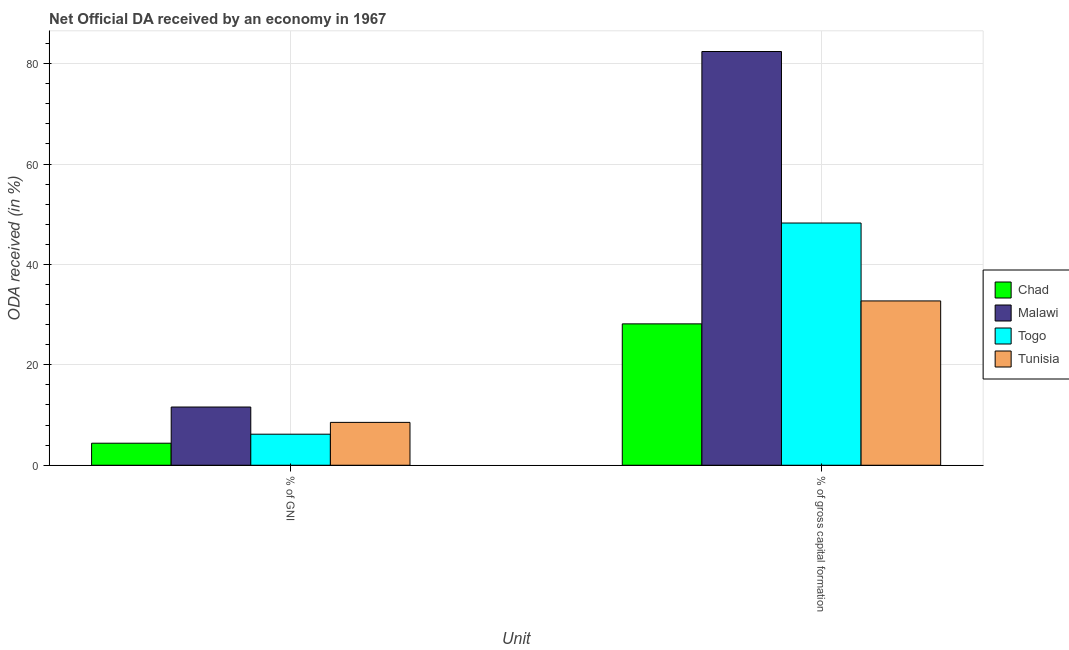How many different coloured bars are there?
Your answer should be compact. 4. How many groups of bars are there?
Keep it short and to the point. 2. What is the label of the 2nd group of bars from the left?
Keep it short and to the point. % of gross capital formation. What is the oda received as percentage of gni in Malawi?
Offer a terse response. 11.6. Across all countries, what is the maximum oda received as percentage of gni?
Your answer should be compact. 11.6. Across all countries, what is the minimum oda received as percentage of gross capital formation?
Offer a very short reply. 28.16. In which country was the oda received as percentage of gross capital formation maximum?
Provide a short and direct response. Malawi. In which country was the oda received as percentage of gni minimum?
Your answer should be compact. Chad. What is the total oda received as percentage of gross capital formation in the graph?
Give a very brief answer. 191.54. What is the difference between the oda received as percentage of gross capital formation in Tunisia and that in Chad?
Your response must be concise. 4.57. What is the difference between the oda received as percentage of gni in Tunisia and the oda received as percentage of gross capital formation in Chad?
Your response must be concise. -19.62. What is the average oda received as percentage of gni per country?
Give a very brief answer. 7.68. What is the difference between the oda received as percentage of gni and oda received as percentage of gross capital formation in Chad?
Offer a terse response. -23.77. In how many countries, is the oda received as percentage of gross capital formation greater than 72 %?
Keep it short and to the point. 1. What is the ratio of the oda received as percentage of gni in Chad to that in Togo?
Offer a very short reply. 0.71. In how many countries, is the oda received as percentage of gross capital formation greater than the average oda received as percentage of gross capital formation taken over all countries?
Your response must be concise. 2. What does the 3rd bar from the left in % of gross capital formation represents?
Give a very brief answer. Togo. What does the 2nd bar from the right in % of GNI represents?
Your answer should be compact. Togo. How many bars are there?
Provide a succinct answer. 8. Are all the bars in the graph horizontal?
Keep it short and to the point. No. How many countries are there in the graph?
Offer a terse response. 4. Does the graph contain any zero values?
Your response must be concise. No. How many legend labels are there?
Offer a terse response. 4. How are the legend labels stacked?
Your answer should be compact. Vertical. What is the title of the graph?
Give a very brief answer. Net Official DA received by an economy in 1967. What is the label or title of the X-axis?
Your response must be concise. Unit. What is the label or title of the Y-axis?
Make the answer very short. ODA received (in %). What is the ODA received (in %) in Chad in % of GNI?
Offer a terse response. 4.39. What is the ODA received (in %) of Malawi in % of GNI?
Give a very brief answer. 11.6. What is the ODA received (in %) of Togo in % of GNI?
Provide a succinct answer. 6.18. What is the ODA received (in %) in Tunisia in % of GNI?
Offer a terse response. 8.54. What is the ODA received (in %) in Chad in % of gross capital formation?
Provide a short and direct response. 28.16. What is the ODA received (in %) in Malawi in % of gross capital formation?
Keep it short and to the point. 82.41. What is the ODA received (in %) of Togo in % of gross capital formation?
Give a very brief answer. 48.24. What is the ODA received (in %) in Tunisia in % of gross capital formation?
Your answer should be compact. 32.73. Across all Unit, what is the maximum ODA received (in %) of Chad?
Give a very brief answer. 28.16. Across all Unit, what is the maximum ODA received (in %) in Malawi?
Keep it short and to the point. 82.41. Across all Unit, what is the maximum ODA received (in %) in Togo?
Your answer should be very brief. 48.24. Across all Unit, what is the maximum ODA received (in %) of Tunisia?
Provide a succinct answer. 32.73. Across all Unit, what is the minimum ODA received (in %) of Chad?
Give a very brief answer. 4.39. Across all Unit, what is the minimum ODA received (in %) of Malawi?
Your answer should be compact. 11.6. Across all Unit, what is the minimum ODA received (in %) in Togo?
Offer a terse response. 6.18. Across all Unit, what is the minimum ODA received (in %) of Tunisia?
Provide a short and direct response. 8.54. What is the total ODA received (in %) of Chad in the graph?
Offer a very short reply. 32.54. What is the total ODA received (in %) in Malawi in the graph?
Provide a succinct answer. 94. What is the total ODA received (in %) of Togo in the graph?
Make the answer very short. 54.43. What is the total ODA received (in %) of Tunisia in the graph?
Provide a succinct answer. 41.26. What is the difference between the ODA received (in %) of Chad in % of GNI and that in % of gross capital formation?
Make the answer very short. -23.77. What is the difference between the ODA received (in %) in Malawi in % of GNI and that in % of gross capital formation?
Make the answer very short. -70.81. What is the difference between the ODA received (in %) of Togo in % of GNI and that in % of gross capital formation?
Your answer should be compact. -42.06. What is the difference between the ODA received (in %) of Tunisia in % of GNI and that in % of gross capital formation?
Make the answer very short. -24.19. What is the difference between the ODA received (in %) in Chad in % of GNI and the ODA received (in %) in Malawi in % of gross capital formation?
Provide a succinct answer. -78.02. What is the difference between the ODA received (in %) in Chad in % of GNI and the ODA received (in %) in Togo in % of gross capital formation?
Offer a terse response. -43.86. What is the difference between the ODA received (in %) in Chad in % of GNI and the ODA received (in %) in Tunisia in % of gross capital formation?
Ensure brevity in your answer.  -28.34. What is the difference between the ODA received (in %) in Malawi in % of GNI and the ODA received (in %) in Togo in % of gross capital formation?
Your answer should be compact. -36.65. What is the difference between the ODA received (in %) of Malawi in % of GNI and the ODA received (in %) of Tunisia in % of gross capital formation?
Your answer should be very brief. -21.13. What is the difference between the ODA received (in %) in Togo in % of GNI and the ODA received (in %) in Tunisia in % of gross capital formation?
Offer a very short reply. -26.54. What is the average ODA received (in %) in Chad per Unit?
Give a very brief answer. 16.27. What is the average ODA received (in %) of Malawi per Unit?
Your answer should be compact. 47. What is the average ODA received (in %) of Togo per Unit?
Your answer should be compact. 27.21. What is the average ODA received (in %) in Tunisia per Unit?
Provide a succinct answer. 20.63. What is the difference between the ODA received (in %) of Chad and ODA received (in %) of Malawi in % of GNI?
Give a very brief answer. -7.21. What is the difference between the ODA received (in %) of Chad and ODA received (in %) of Togo in % of GNI?
Offer a very short reply. -1.8. What is the difference between the ODA received (in %) in Chad and ODA received (in %) in Tunisia in % of GNI?
Provide a short and direct response. -4.15. What is the difference between the ODA received (in %) of Malawi and ODA received (in %) of Togo in % of GNI?
Ensure brevity in your answer.  5.41. What is the difference between the ODA received (in %) in Malawi and ODA received (in %) in Tunisia in % of GNI?
Provide a short and direct response. 3.06. What is the difference between the ODA received (in %) in Togo and ODA received (in %) in Tunisia in % of GNI?
Keep it short and to the point. -2.35. What is the difference between the ODA received (in %) of Chad and ODA received (in %) of Malawi in % of gross capital formation?
Your response must be concise. -54.25. What is the difference between the ODA received (in %) of Chad and ODA received (in %) of Togo in % of gross capital formation?
Provide a succinct answer. -20.09. What is the difference between the ODA received (in %) of Chad and ODA received (in %) of Tunisia in % of gross capital formation?
Your answer should be compact. -4.57. What is the difference between the ODA received (in %) in Malawi and ODA received (in %) in Togo in % of gross capital formation?
Offer a terse response. 34.16. What is the difference between the ODA received (in %) of Malawi and ODA received (in %) of Tunisia in % of gross capital formation?
Make the answer very short. 49.68. What is the difference between the ODA received (in %) in Togo and ODA received (in %) in Tunisia in % of gross capital formation?
Give a very brief answer. 15.52. What is the ratio of the ODA received (in %) of Chad in % of GNI to that in % of gross capital formation?
Give a very brief answer. 0.16. What is the ratio of the ODA received (in %) of Malawi in % of GNI to that in % of gross capital formation?
Keep it short and to the point. 0.14. What is the ratio of the ODA received (in %) in Togo in % of GNI to that in % of gross capital formation?
Provide a short and direct response. 0.13. What is the ratio of the ODA received (in %) of Tunisia in % of GNI to that in % of gross capital formation?
Your answer should be compact. 0.26. What is the difference between the highest and the second highest ODA received (in %) in Chad?
Your response must be concise. 23.77. What is the difference between the highest and the second highest ODA received (in %) of Malawi?
Your answer should be very brief. 70.81. What is the difference between the highest and the second highest ODA received (in %) in Togo?
Offer a terse response. 42.06. What is the difference between the highest and the second highest ODA received (in %) in Tunisia?
Make the answer very short. 24.19. What is the difference between the highest and the lowest ODA received (in %) in Chad?
Your answer should be very brief. 23.77. What is the difference between the highest and the lowest ODA received (in %) in Malawi?
Offer a very short reply. 70.81. What is the difference between the highest and the lowest ODA received (in %) in Togo?
Offer a terse response. 42.06. What is the difference between the highest and the lowest ODA received (in %) of Tunisia?
Keep it short and to the point. 24.19. 